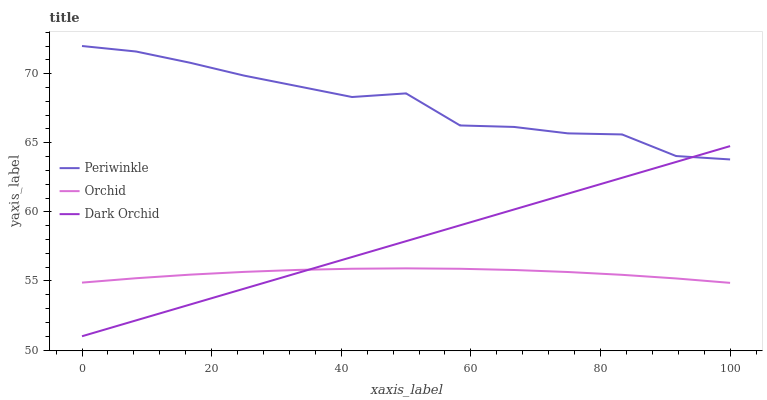Does Orchid have the minimum area under the curve?
Answer yes or no. Yes. Does Periwinkle have the maximum area under the curve?
Answer yes or no. Yes. Does Dark Orchid have the minimum area under the curve?
Answer yes or no. No. Does Dark Orchid have the maximum area under the curve?
Answer yes or no. No. Is Dark Orchid the smoothest?
Answer yes or no. Yes. Is Periwinkle the roughest?
Answer yes or no. Yes. Is Orchid the smoothest?
Answer yes or no. No. Is Orchid the roughest?
Answer yes or no. No. Does Dark Orchid have the lowest value?
Answer yes or no. Yes. Does Orchid have the lowest value?
Answer yes or no. No. Does Periwinkle have the highest value?
Answer yes or no. Yes. Does Dark Orchid have the highest value?
Answer yes or no. No. Is Orchid less than Periwinkle?
Answer yes or no. Yes. Is Periwinkle greater than Orchid?
Answer yes or no. Yes. Does Dark Orchid intersect Periwinkle?
Answer yes or no. Yes. Is Dark Orchid less than Periwinkle?
Answer yes or no. No. Is Dark Orchid greater than Periwinkle?
Answer yes or no. No. Does Orchid intersect Periwinkle?
Answer yes or no. No. 